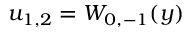<formula> <loc_0><loc_0><loc_500><loc_500>u _ { 1 , 2 } = W _ { 0 , - 1 } ( y )</formula> 